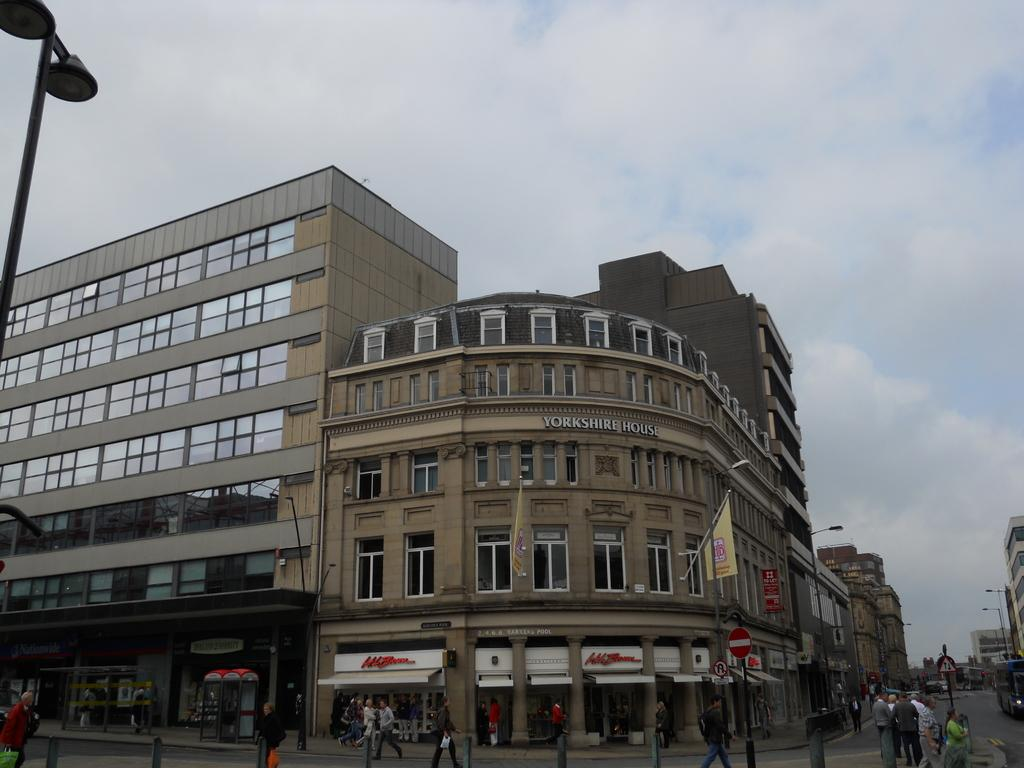What type of structures can be seen in the image? There are buildings in the image. What else can be seen besides the buildings? There are poles, a flag, lights, boards, and people on the road in the image. What is the weather like in the image? There are clouds in the sky at the top of the image, indicating that it might be partly cloudy. How many times does the picture fall in the image? There is no picture present in the image, so it cannot fall. What type of test is being conducted on the road in the image? There is no test being conducted on the road in the image; it simply shows people walking or standing. 